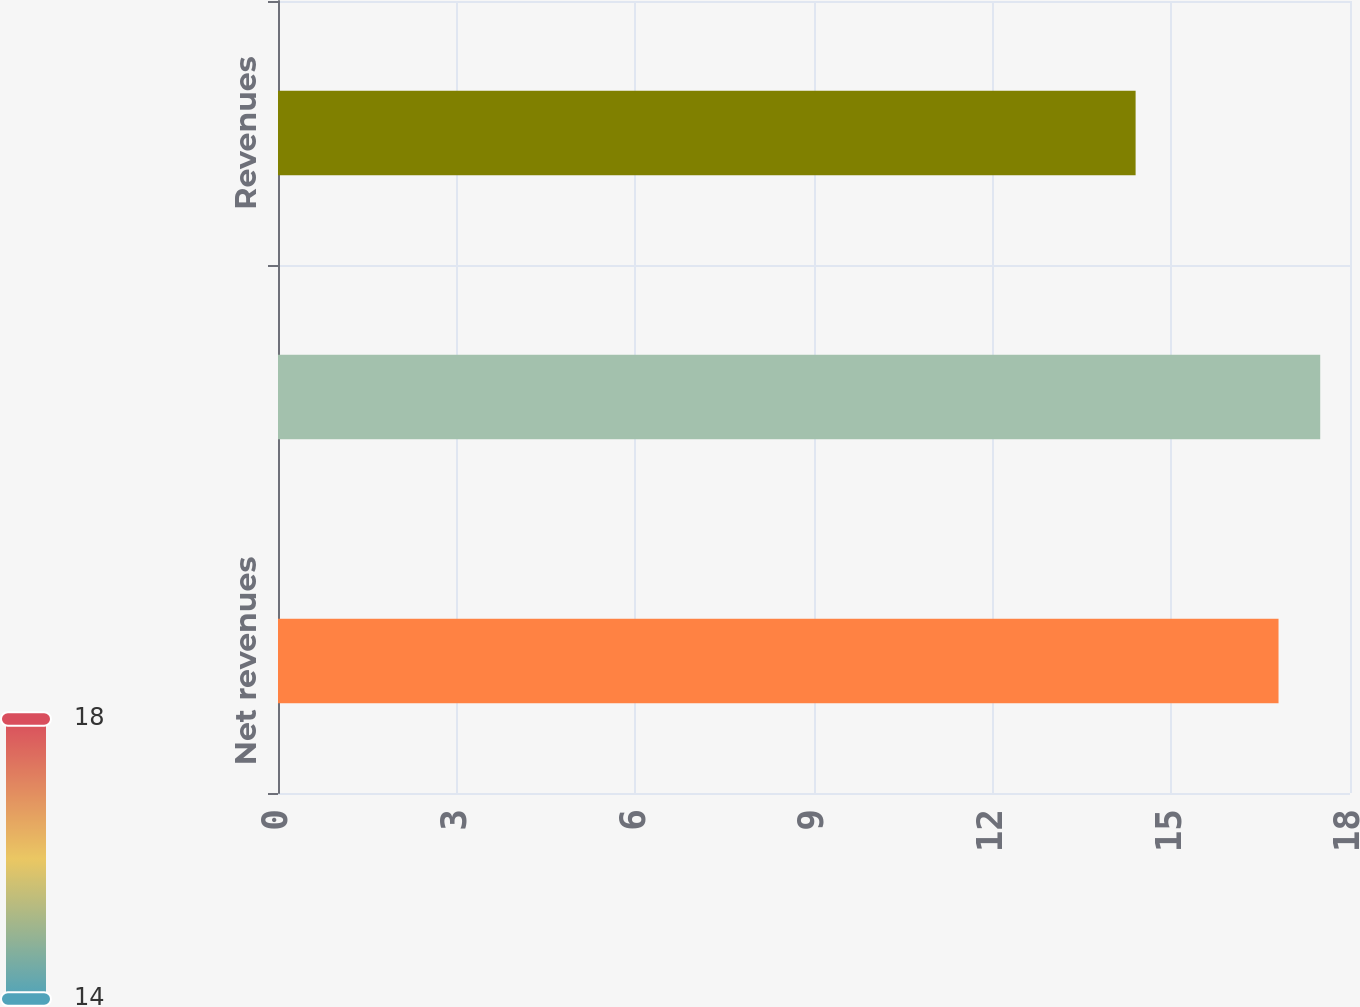Convert chart. <chart><loc_0><loc_0><loc_500><loc_500><bar_chart><fcel>Net revenues<fcel>Assets<fcel>Revenues<nl><fcel>16.8<fcel>17.5<fcel>14.4<nl></chart> 